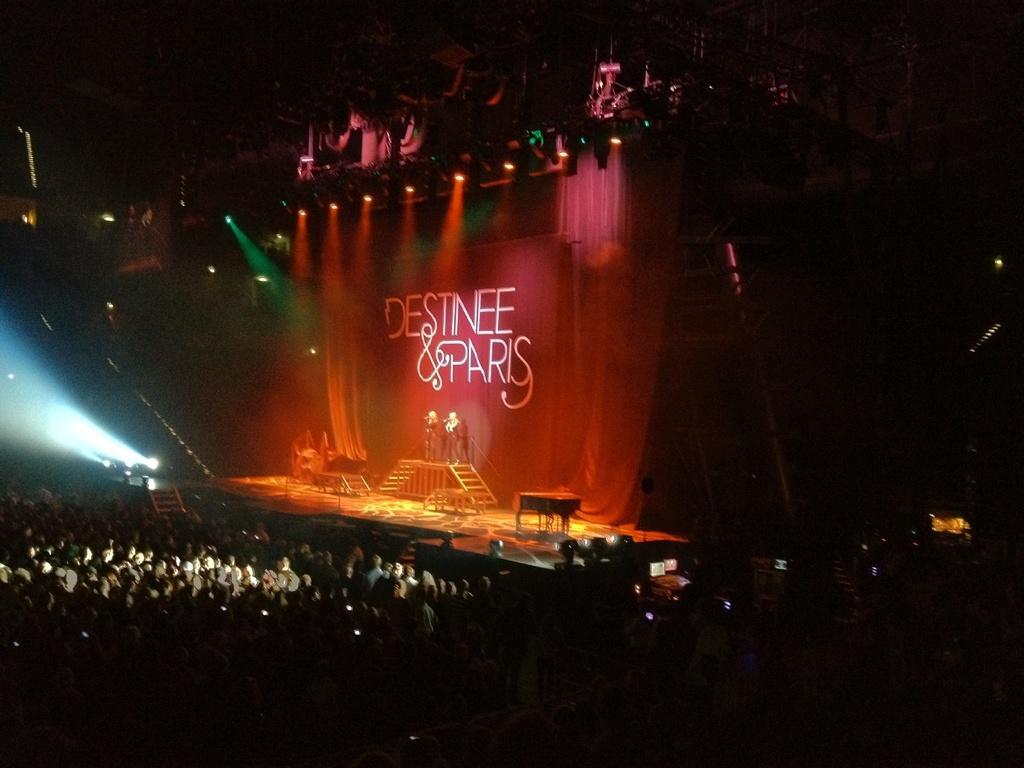In one or two sentences, can you explain what this image depicts? In this picture we can see a group of people, some people are on the stage, here we can see lights, poster, steps and some objects and in the background we can see it is dark. 